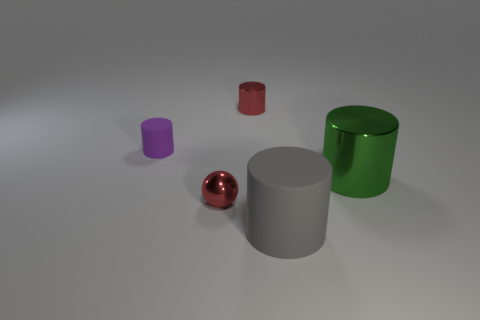There is a object that is both to the right of the ball and in front of the big metallic cylinder; what is it made of?
Keep it short and to the point. Rubber. There is a thing that is the same size as the gray cylinder; what shape is it?
Offer a very short reply. Cylinder. There is a tiny thing in front of the large shiny cylinder right of the rubber object on the left side of the big gray cylinder; what color is it?
Your answer should be compact. Red. How many things are tiny things that are in front of the green shiny cylinder or tiny red metal cylinders?
Your response must be concise. 2. There is a red cylinder that is the same size as the red metallic sphere; what is its material?
Offer a terse response. Metal. There is a red thing that is to the left of the metal cylinder to the left of the matte object in front of the green shiny thing; what is its material?
Your answer should be compact. Metal. What color is the tiny metallic ball?
Your answer should be very brief. Red. How many big objects are either yellow shiny cylinders or metallic balls?
Offer a terse response. 0. Does the tiny purple thing that is left of the tiny red cylinder have the same material as the cylinder behind the purple thing?
Offer a terse response. No. Are any gray shiny spheres visible?
Keep it short and to the point. No. 